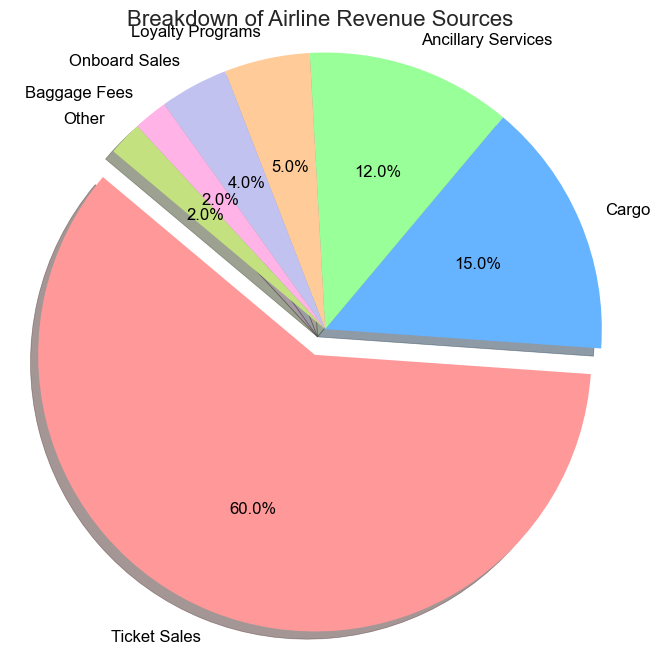Which revenue source contributes the most to the airline's revenue? The largest slice of the pie chart, which is 60%, corresponds to Ticket Sales. This indicates that Ticket Sales is the highest revenue contributor.
Answer: Ticket Sales What percentage of the revenue comes from Cargo and Ancillary Services combined? To find the combined percentage, we add the percentages for Cargo (15%) and Ancillary Services (12%), which is 15% + 12% = 27%.
Answer: 27% Which revenue source has a lower contribution: Loyalty Programs or Onboard Sales? By comparing the percentages, Loyalty Programs contribute 5% and Onboard Sales contribute 4%. Since 4% is less than 5%, Onboard Sales has a lower contribution.
Answer: Onboard Sales How much more does Ticket Sales contribute compared to Baggage Fees? Ticket Sales contribute 60%, and Baggage Fees contribute 2%. The difference is 60% - 2% = 58%.
Answer: 58% Is the sum of the percentages for Onboard Sales and Baggage Fees equal to the percentage for Ancillary Services? Onboard Sales and Baggage Fees contribute 4% and 2%, respectively. Their sum is 4% + 2% = 6%, which is not equal to the 12% contributed by Ancillary Services.
Answer: No What is the difference in percentage between the highest and lowest revenue sources? The highest revenue source is Ticket Sales at 60%, and the lowest revenue sources are Baggage Fees and Other at 2% each. The difference is 60% - 2% = 58%.
Answer: 58% Are Cargo and Loyalty Programs visually represented using different colors? By examining the pie chart, we can see that each segment is represented by a unique color extracted from a distinct palette. Thus, Cargo and Loyalty Programs each have different colors.
Answer: Yes What is the combined percentage of the revenue sourced from Loyalty Programs, Onboard Sales, and Baggage Fees? Loyalty Programs (5%), Onboard Sales (4%), and Baggage Fees (2%) contribute a combined percentage of 5% + 4% + 2% = 11%.
Answer: 11% Is the portion for Ancillary Services visually larger than that for Loyalty Programs? Ancillary Services represent 12%, and Loyalty Programs represent 5%. Since 12% is larger than 5%, the portion for Ancillary Services is visually larger.
Answer: Yes 